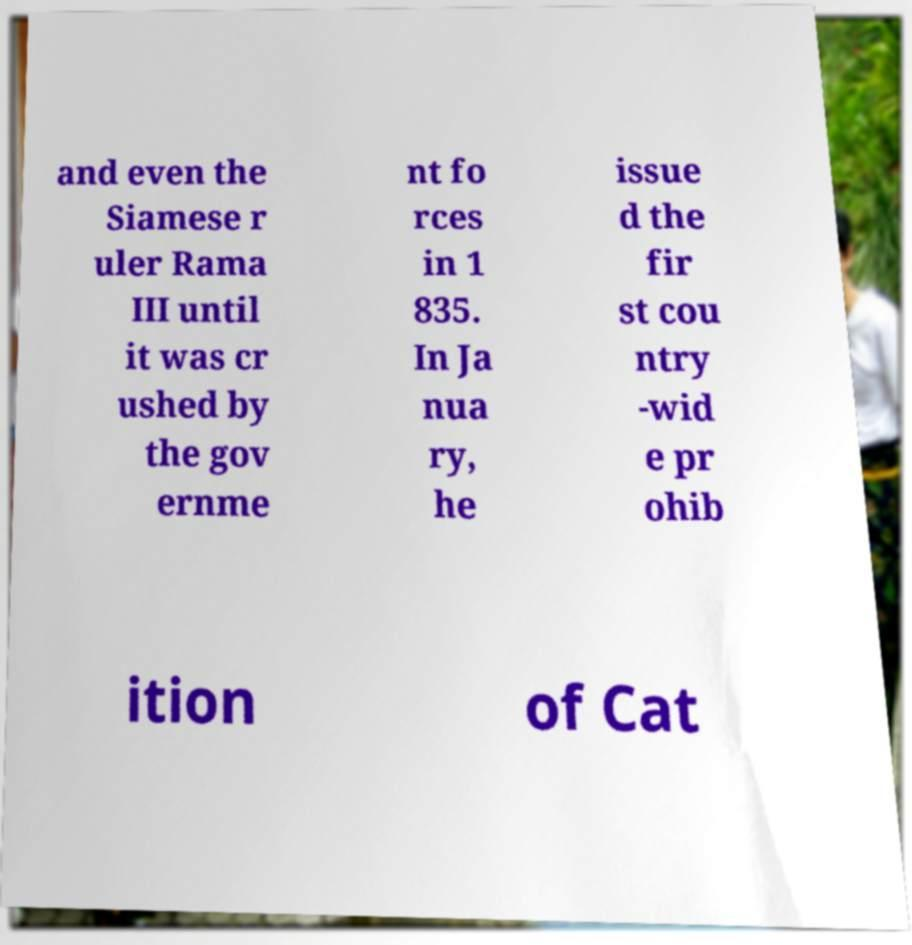What messages or text are displayed in this image? I need them in a readable, typed format. and even the Siamese r uler Rama III until it was cr ushed by the gov ernme nt fo rces in 1 835. In Ja nua ry, he issue d the fir st cou ntry -wid e pr ohib ition of Cat 